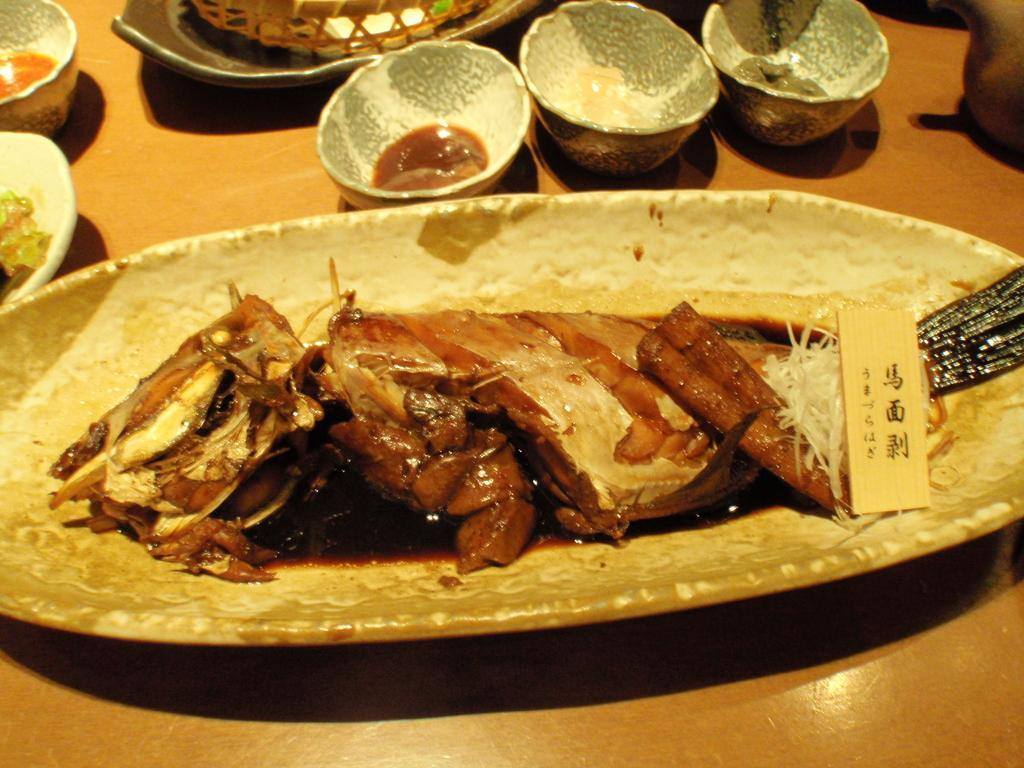What is on the plate that is visible in the image? There is food on the plate in the image. Besides the plate, what other dishware can be seen in the image? There are bowls in the image. What type of surface is the plate and bowls resting on? The wooden platform is present in the image. What rhythm do the men follow while dancing on the wooden platform in the image? There are no men or dancing present in the image; it only features a plate, food, bowls, and a wooden platform. 